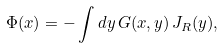Convert formula to latex. <formula><loc_0><loc_0><loc_500><loc_500>\Phi ( x ) = - \int d y \, G ( x , y ) \, J _ { R } ( y ) ,</formula> 